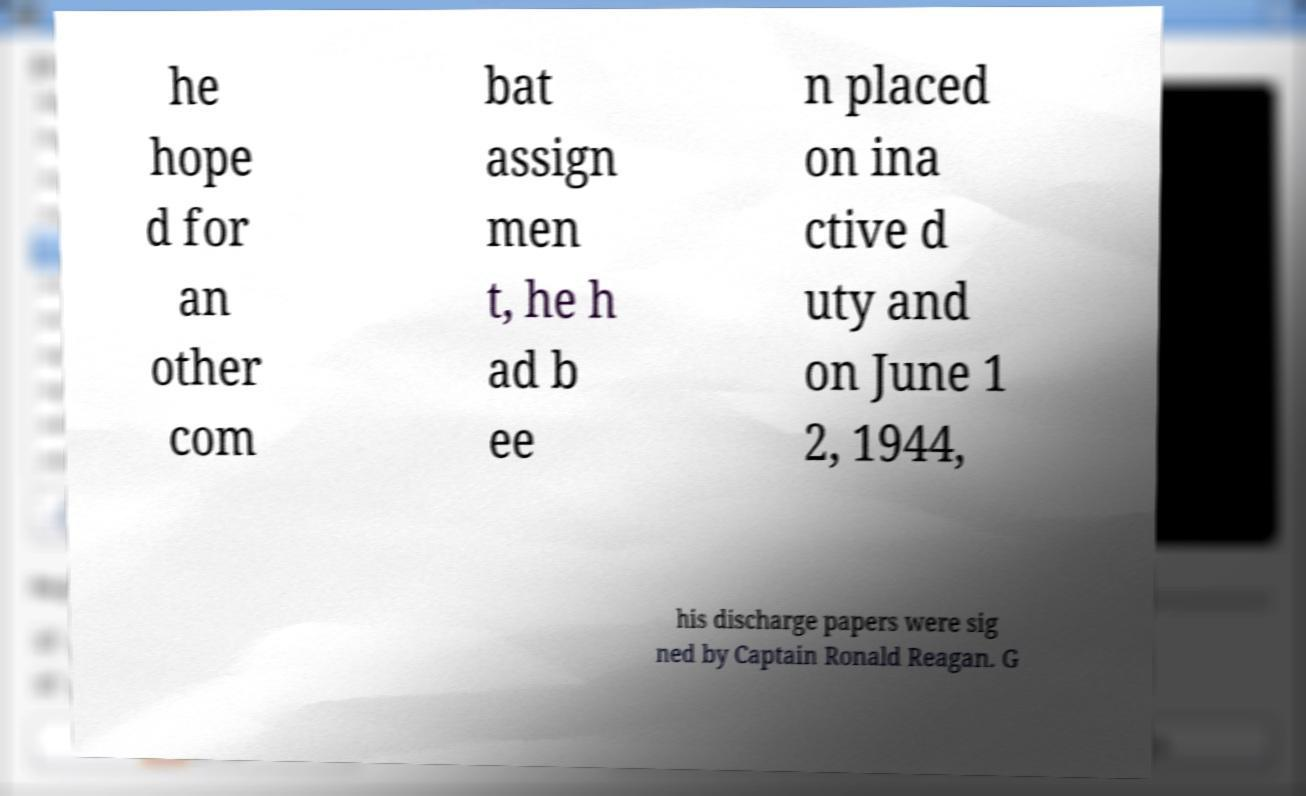There's text embedded in this image that I need extracted. Can you transcribe it verbatim? he hope d for an other com bat assign men t, he h ad b ee n placed on ina ctive d uty and on June 1 2, 1944, his discharge papers were sig ned by Captain Ronald Reagan. G 